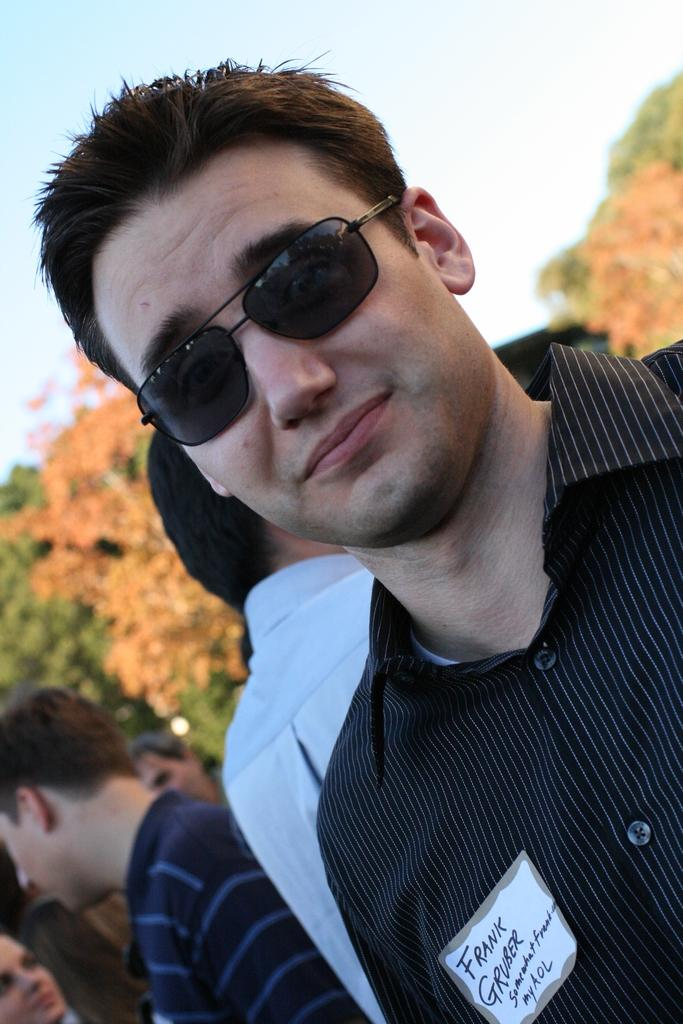Who is the main subject in the image? There is a man in the image. What is the man wearing in the image? The man is wearing spectacles. What can be seen in the background of the image? There are people, trees, and the sky visible in the background of the image. Can you tell me how many yokes are being used by the people in the image? There is no yoke present in the image; it features a man wearing spectacles and a background with people, trees, and the sky. What type of land can be seen in the image? The image does not show any specific type of land; it only features a man, spectacles, and a background with people, trees, and the sky. 